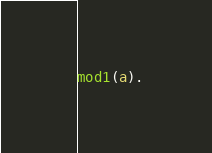<code> <loc_0><loc_0><loc_500><loc_500><_Prolog_>
mod1(a).

</code> 